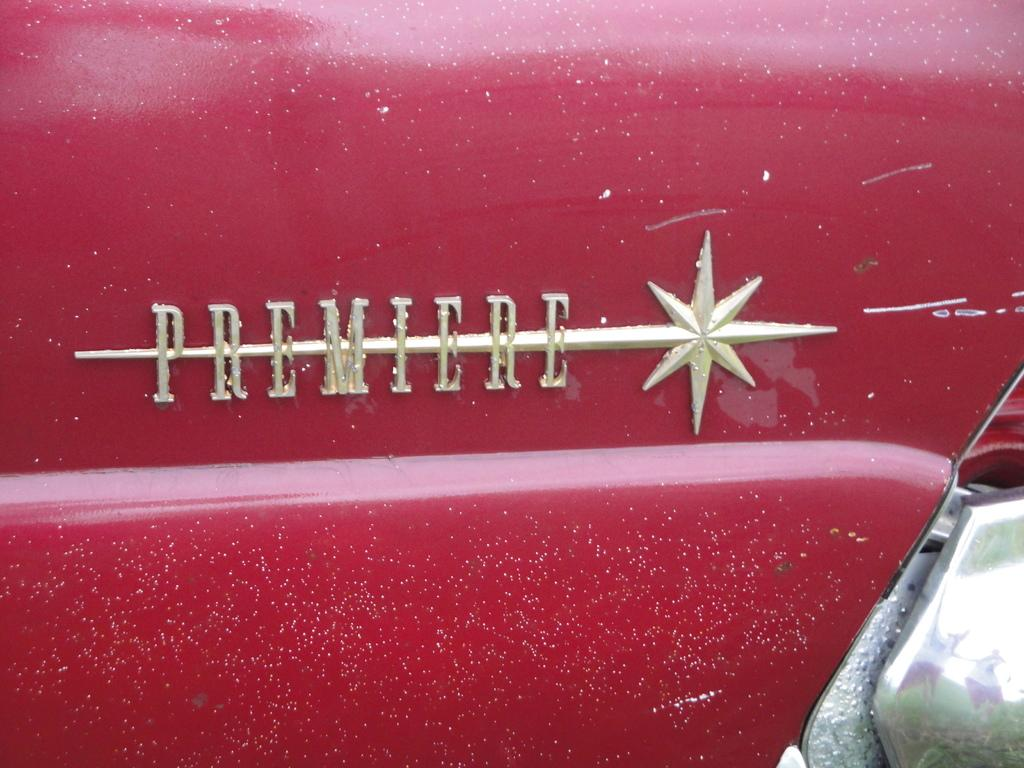What type of vehicle is in the image? There is a red color vehicle in the image. What can be seen on the vehicle besides its color? The vehicle has a name and a symbol on it. Can you see the guitar being played inside the vehicle in the image? There is no guitar or any indication of someone playing a guitar inside the vehicle in the image. 